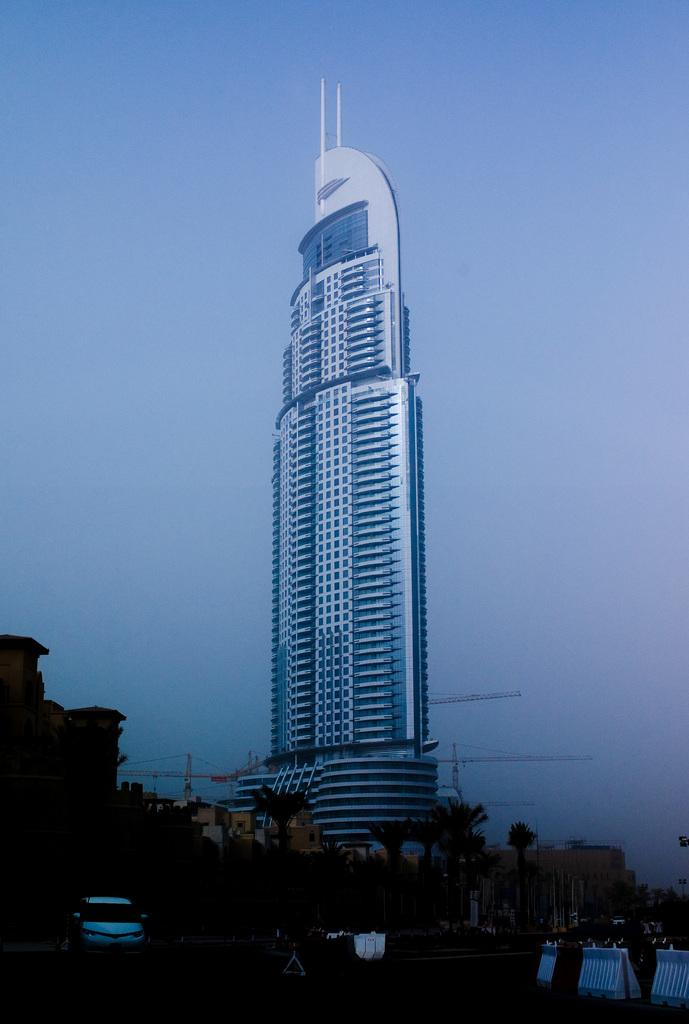What is in the foreground of the image? There is a road in the foreground of the image. What types of objects can be seen on the road? There are vehicles in the image. What natural elements are present in the image? There are trees in the image. What man-made structures are visible in the image? There are buildings and electric poles in the image. Can you describe the tallest building in the image? There is a tall building in the image. What part of the natural environment is visible in the image? The sky is visible in the image. Are there any horses or a zoo visible in the image? No, there are no horses or a zoo present in the image. What type of wire can be seen connecting the electric poles in the image? There is no wire connecting the electric poles visible in the image. 